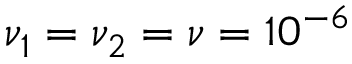Convert formula to latex. <formula><loc_0><loc_0><loc_500><loc_500>\nu _ { 1 } = \nu _ { 2 } = \nu = 1 0 ^ { - 6 }</formula> 